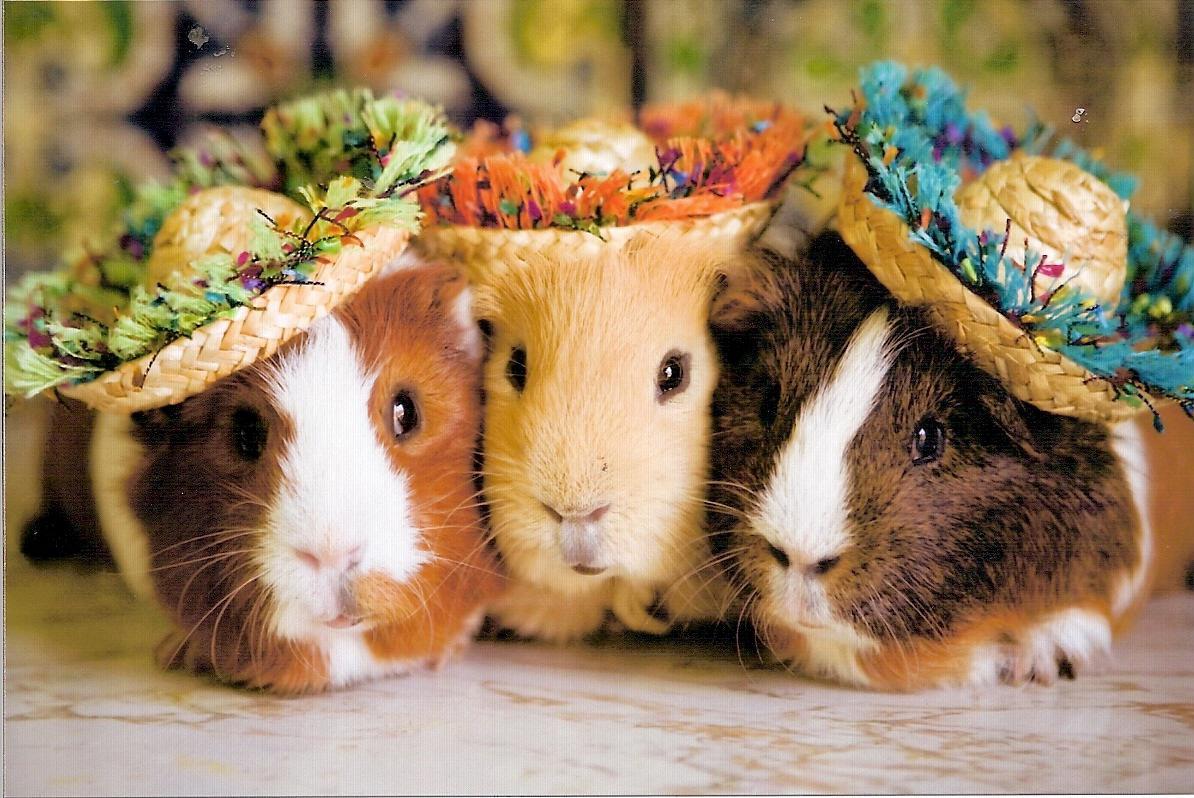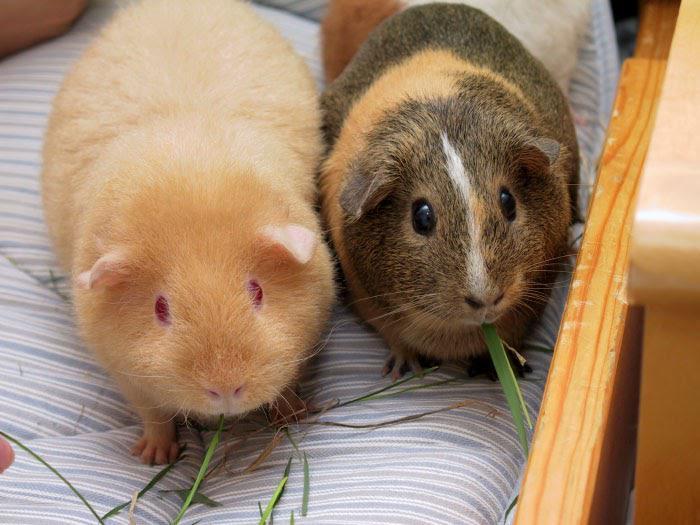The first image is the image on the left, the second image is the image on the right. Given the left and right images, does the statement "An image shows a pair of hamsters nibbling on something green." hold true? Answer yes or no. Yes. The first image is the image on the left, the second image is the image on the right. Analyze the images presented: Is the assertion "There is at least one guinea pig eating a green food item" valid? Answer yes or no. Yes. 